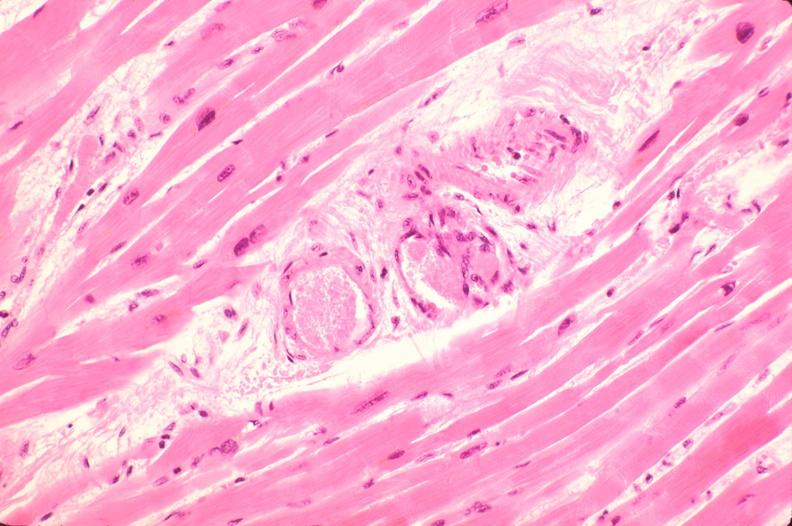s heart present?
Answer the question using a single word or phrase. No 